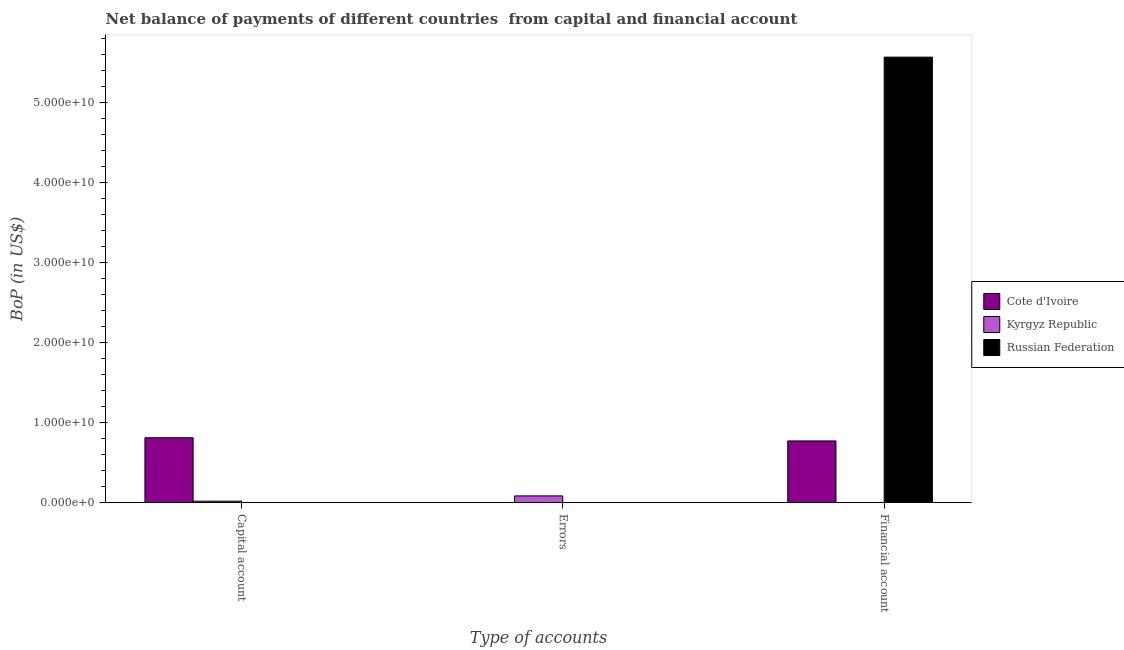How many different coloured bars are there?
Your response must be concise. 3. Are the number of bars per tick equal to the number of legend labels?
Give a very brief answer. No. Are the number of bars on each tick of the X-axis equal?
Make the answer very short. No. How many bars are there on the 3rd tick from the left?
Provide a succinct answer. 2. What is the label of the 3rd group of bars from the left?
Give a very brief answer. Financial account. What is the amount of errors in Kyrgyz Republic?
Make the answer very short. 8.44e+08. Across all countries, what is the maximum amount of errors?
Ensure brevity in your answer.  8.44e+08. Across all countries, what is the minimum amount of errors?
Keep it short and to the point. 0. In which country was the amount of financial account maximum?
Offer a terse response. Russian Federation. What is the total amount of financial account in the graph?
Provide a succinct answer. 6.34e+1. What is the difference between the amount of financial account in Cote d'Ivoire and that in Russian Federation?
Give a very brief answer. -4.80e+1. What is the difference between the amount of errors in Cote d'Ivoire and the amount of net capital account in Kyrgyz Republic?
Make the answer very short. -1.84e+08. What is the average amount of errors per country?
Your answer should be compact. 2.81e+08. In how many countries, is the amount of errors greater than 28000000000 US$?
Make the answer very short. 0. What is the ratio of the amount of financial account in Cote d'Ivoire to that in Russian Federation?
Keep it short and to the point. 0.14. What is the difference between the highest and the lowest amount of financial account?
Offer a terse response. 5.57e+1. Is it the case that in every country, the sum of the amount of net capital account and amount of errors is greater than the amount of financial account?
Give a very brief answer. No. Are all the bars in the graph horizontal?
Give a very brief answer. No. How many countries are there in the graph?
Give a very brief answer. 3. What is the difference between two consecutive major ticks on the Y-axis?
Your answer should be very brief. 1.00e+1. How many legend labels are there?
Provide a succinct answer. 3. What is the title of the graph?
Provide a succinct answer. Net balance of payments of different countries  from capital and financial account. Does "Euro area" appear as one of the legend labels in the graph?
Your response must be concise. No. What is the label or title of the X-axis?
Give a very brief answer. Type of accounts. What is the label or title of the Y-axis?
Offer a terse response. BoP (in US$). What is the BoP (in US$) of Cote d'Ivoire in Capital account?
Ensure brevity in your answer.  8.11e+09. What is the BoP (in US$) of Kyrgyz Republic in Capital account?
Your answer should be compact. 1.84e+08. What is the BoP (in US$) of Russian Federation in Capital account?
Offer a very short reply. 0. What is the BoP (in US$) of Cote d'Ivoire in Errors?
Your response must be concise. 0. What is the BoP (in US$) in Kyrgyz Republic in Errors?
Keep it short and to the point. 8.44e+08. What is the BoP (in US$) in Russian Federation in Errors?
Offer a very short reply. 0. What is the BoP (in US$) of Cote d'Ivoire in Financial account?
Provide a succinct answer. 7.71e+09. What is the BoP (in US$) in Kyrgyz Republic in Financial account?
Offer a terse response. 0. What is the BoP (in US$) of Russian Federation in Financial account?
Ensure brevity in your answer.  5.57e+1. Across all Type of accounts, what is the maximum BoP (in US$) in Cote d'Ivoire?
Provide a short and direct response. 8.11e+09. Across all Type of accounts, what is the maximum BoP (in US$) in Kyrgyz Republic?
Give a very brief answer. 8.44e+08. Across all Type of accounts, what is the maximum BoP (in US$) in Russian Federation?
Give a very brief answer. 5.57e+1. What is the total BoP (in US$) in Cote d'Ivoire in the graph?
Give a very brief answer. 1.58e+1. What is the total BoP (in US$) in Kyrgyz Republic in the graph?
Ensure brevity in your answer.  1.03e+09. What is the total BoP (in US$) of Russian Federation in the graph?
Your answer should be very brief. 5.57e+1. What is the difference between the BoP (in US$) in Kyrgyz Republic in Capital account and that in Errors?
Offer a very short reply. -6.60e+08. What is the difference between the BoP (in US$) of Cote d'Ivoire in Capital account and that in Financial account?
Offer a very short reply. 3.97e+08. What is the difference between the BoP (in US$) of Cote d'Ivoire in Capital account and the BoP (in US$) of Kyrgyz Republic in Errors?
Make the answer very short. 7.27e+09. What is the difference between the BoP (in US$) in Cote d'Ivoire in Capital account and the BoP (in US$) in Russian Federation in Financial account?
Your response must be concise. -4.76e+1. What is the difference between the BoP (in US$) in Kyrgyz Republic in Capital account and the BoP (in US$) in Russian Federation in Financial account?
Offer a terse response. -5.55e+1. What is the difference between the BoP (in US$) of Kyrgyz Republic in Errors and the BoP (in US$) of Russian Federation in Financial account?
Ensure brevity in your answer.  -5.48e+1. What is the average BoP (in US$) of Cote d'Ivoire per Type of accounts?
Your answer should be very brief. 5.28e+09. What is the average BoP (in US$) in Kyrgyz Republic per Type of accounts?
Your answer should be very brief. 3.42e+08. What is the average BoP (in US$) of Russian Federation per Type of accounts?
Offer a very short reply. 1.86e+1. What is the difference between the BoP (in US$) in Cote d'Ivoire and BoP (in US$) in Kyrgyz Republic in Capital account?
Provide a succinct answer. 7.93e+09. What is the difference between the BoP (in US$) in Cote d'Ivoire and BoP (in US$) in Russian Federation in Financial account?
Ensure brevity in your answer.  -4.80e+1. What is the ratio of the BoP (in US$) of Kyrgyz Republic in Capital account to that in Errors?
Your response must be concise. 0.22. What is the ratio of the BoP (in US$) of Cote d'Ivoire in Capital account to that in Financial account?
Give a very brief answer. 1.05. What is the difference between the highest and the lowest BoP (in US$) in Cote d'Ivoire?
Your answer should be compact. 8.11e+09. What is the difference between the highest and the lowest BoP (in US$) of Kyrgyz Republic?
Ensure brevity in your answer.  8.44e+08. What is the difference between the highest and the lowest BoP (in US$) in Russian Federation?
Your answer should be very brief. 5.57e+1. 